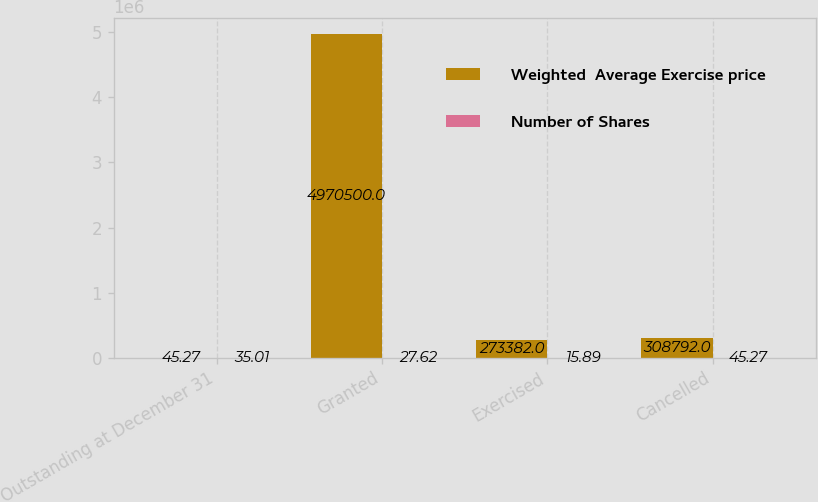Convert chart. <chart><loc_0><loc_0><loc_500><loc_500><stacked_bar_chart><ecel><fcel>Outstanding at December 31<fcel>Granted<fcel>Exercised<fcel>Cancelled<nl><fcel>Weighted  Average Exercise price<fcel>45.27<fcel>4.9705e+06<fcel>273382<fcel>308792<nl><fcel>Number of Shares<fcel>35.01<fcel>27.62<fcel>15.89<fcel>45.27<nl></chart> 